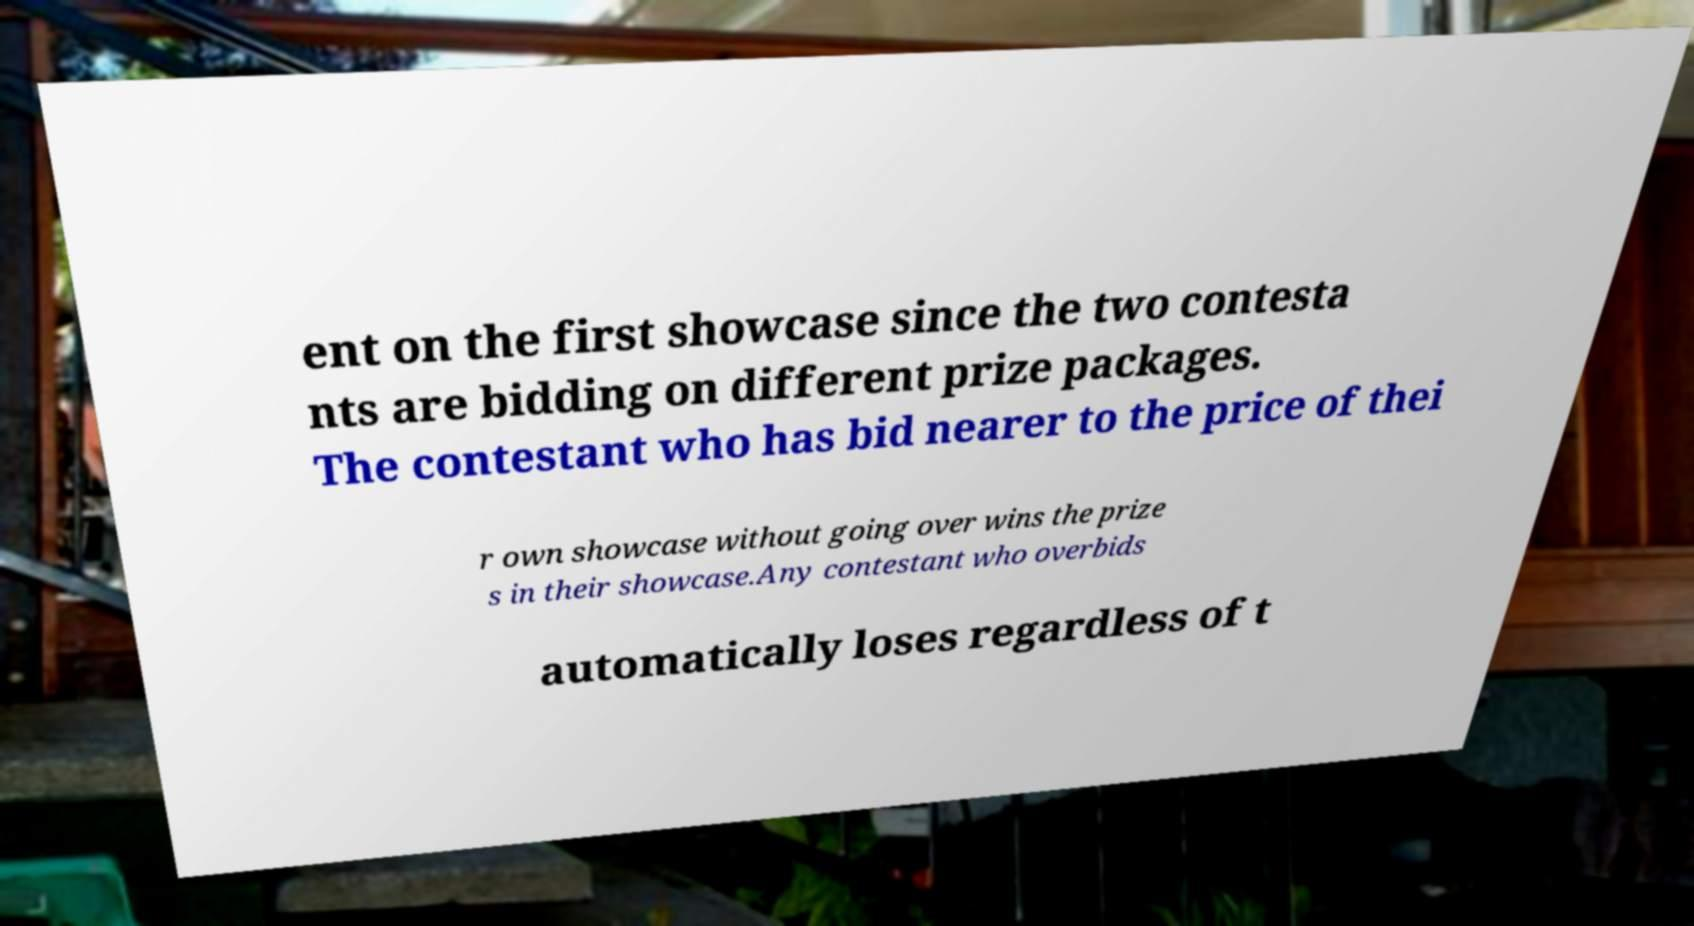Can you accurately transcribe the text from the provided image for me? ent on the first showcase since the two contesta nts are bidding on different prize packages. The contestant who has bid nearer to the price of thei r own showcase without going over wins the prize s in their showcase.Any contestant who overbids automatically loses regardless of t 